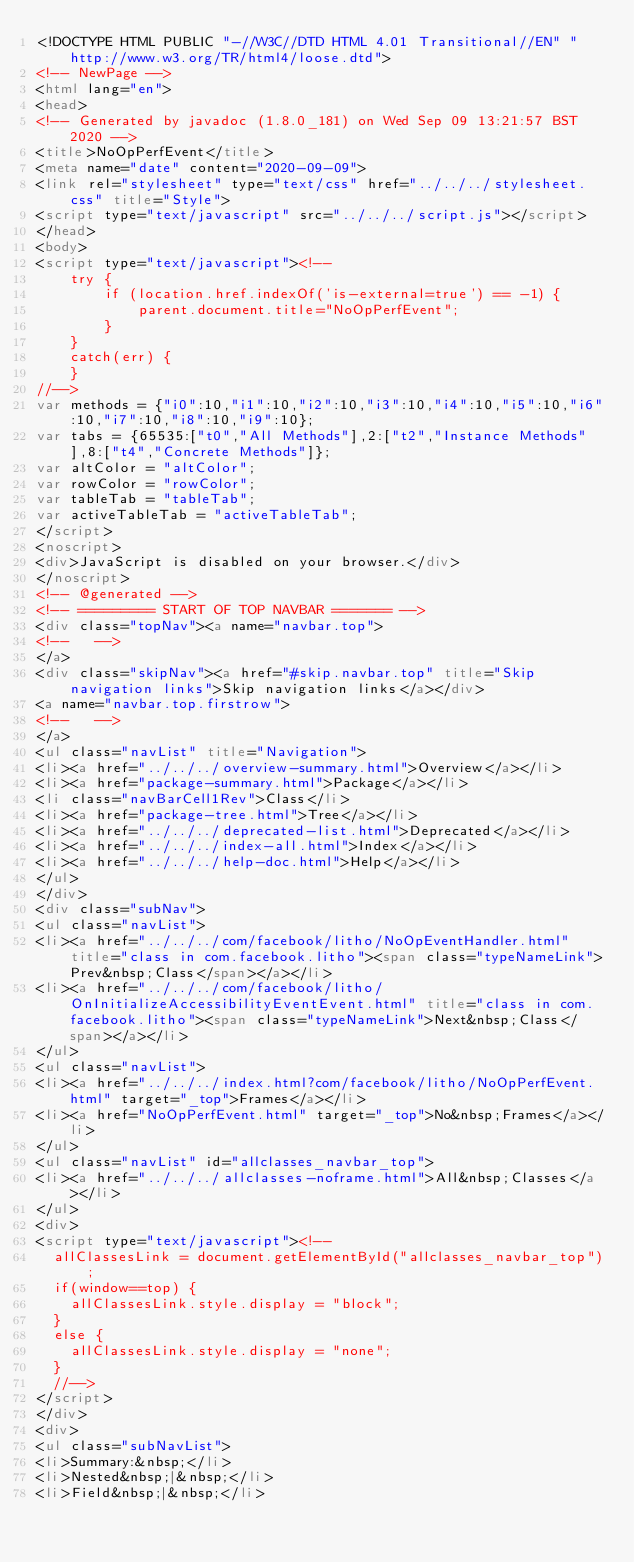Convert code to text. <code><loc_0><loc_0><loc_500><loc_500><_HTML_><!DOCTYPE HTML PUBLIC "-//W3C//DTD HTML 4.01 Transitional//EN" "http://www.w3.org/TR/html4/loose.dtd">
<!-- NewPage -->
<html lang="en">
<head>
<!-- Generated by javadoc (1.8.0_181) on Wed Sep 09 13:21:57 BST 2020 -->
<title>NoOpPerfEvent</title>
<meta name="date" content="2020-09-09">
<link rel="stylesheet" type="text/css" href="../../../stylesheet.css" title="Style">
<script type="text/javascript" src="../../../script.js"></script>
</head>
<body>
<script type="text/javascript"><!--
    try {
        if (location.href.indexOf('is-external=true') == -1) {
            parent.document.title="NoOpPerfEvent";
        }
    }
    catch(err) {
    }
//-->
var methods = {"i0":10,"i1":10,"i2":10,"i3":10,"i4":10,"i5":10,"i6":10,"i7":10,"i8":10,"i9":10};
var tabs = {65535:["t0","All Methods"],2:["t2","Instance Methods"],8:["t4","Concrete Methods"]};
var altColor = "altColor";
var rowColor = "rowColor";
var tableTab = "tableTab";
var activeTableTab = "activeTableTab";
</script>
<noscript>
<div>JavaScript is disabled on your browser.</div>
</noscript>
<!-- @generated -->
<!-- ========= START OF TOP NAVBAR ======= -->
<div class="topNav"><a name="navbar.top">
<!--   -->
</a>
<div class="skipNav"><a href="#skip.navbar.top" title="Skip navigation links">Skip navigation links</a></div>
<a name="navbar.top.firstrow">
<!--   -->
</a>
<ul class="navList" title="Navigation">
<li><a href="../../../overview-summary.html">Overview</a></li>
<li><a href="package-summary.html">Package</a></li>
<li class="navBarCell1Rev">Class</li>
<li><a href="package-tree.html">Tree</a></li>
<li><a href="../../../deprecated-list.html">Deprecated</a></li>
<li><a href="../../../index-all.html">Index</a></li>
<li><a href="../../../help-doc.html">Help</a></li>
</ul>
</div>
<div class="subNav">
<ul class="navList">
<li><a href="../../../com/facebook/litho/NoOpEventHandler.html" title="class in com.facebook.litho"><span class="typeNameLink">Prev&nbsp;Class</span></a></li>
<li><a href="../../../com/facebook/litho/OnInitializeAccessibilityEventEvent.html" title="class in com.facebook.litho"><span class="typeNameLink">Next&nbsp;Class</span></a></li>
</ul>
<ul class="navList">
<li><a href="../../../index.html?com/facebook/litho/NoOpPerfEvent.html" target="_top">Frames</a></li>
<li><a href="NoOpPerfEvent.html" target="_top">No&nbsp;Frames</a></li>
</ul>
<ul class="navList" id="allclasses_navbar_top">
<li><a href="../../../allclasses-noframe.html">All&nbsp;Classes</a></li>
</ul>
<div>
<script type="text/javascript"><!--
  allClassesLink = document.getElementById("allclasses_navbar_top");
  if(window==top) {
    allClassesLink.style.display = "block";
  }
  else {
    allClassesLink.style.display = "none";
  }
  //-->
</script>
</div>
<div>
<ul class="subNavList">
<li>Summary:&nbsp;</li>
<li>Nested&nbsp;|&nbsp;</li>
<li>Field&nbsp;|&nbsp;</li></code> 